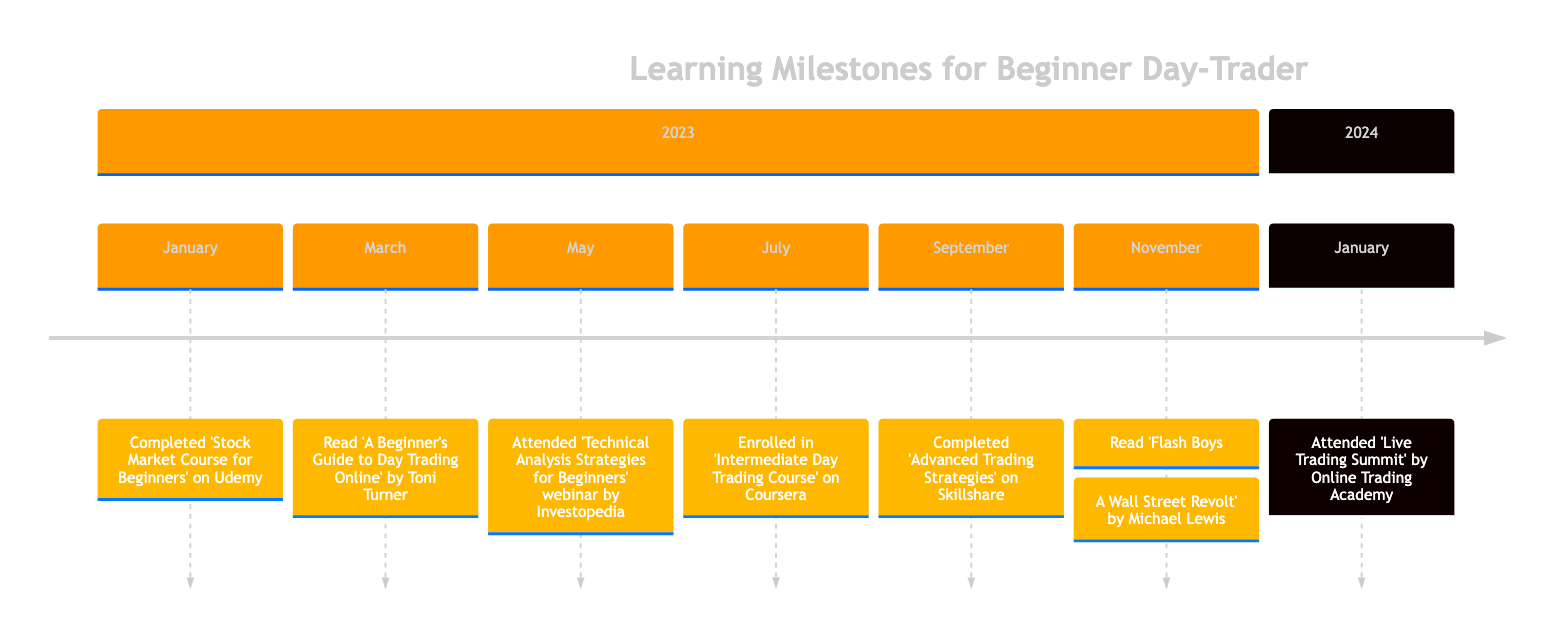What milestone was completed in January 2023? The diagram clearly states that in January 2023, the milestone "Completed 'Stock Market Course for Beginners' on Udemy" is depicted.
Answer: Completed 'Stock Market Course for Beginners' on Udemy How many books are listed in the timeline? By examining the timeline, there are two milestones that mention books, specifically the ones read in March and November.
Answer: 2 What course was taken in July 2023? The milestone for July 2023 specifically mentions enrolling in "Intermediate Day Trading Course" on Coursera.
Answer: Enrolled in 'Intermediate Day Trading Course' on Coursera Which webinar was attended before the advanced trading strategies course? The timeline reveals that the "Technical Analysis Strategies for Beginners" webinar was attended in May 2023, and the "Advanced Trading Strategies" course was completed in September 2023.
Answer: Attended 'Technical Analysis Strategies for Beginners' webinar by Investopedia In which month did the reader complete the advanced trading strategies course? The timeline shows that the "Advanced Trading Strategies" course was completed in September 2023.
Answer: September What was the last milestone recorded in the timeline? Looking at the timeline, the last entry is "Attended 'Live Trading Summit' by Online Trading Academy" in January 2024.
Answer: Attended 'Live Trading Summit' by Online Trading Academy Which book is focused on high-frequency trading? The diagram highlights "Flash Boys: A Wall Street Revolt" by Michael Lewis as the book that deals with high-frequency trading.
Answer: Flash Boys: A Wall Street Revolt What type of event was the "Live Trading Summit"? The timeline presents the "Live Trading Summit" as a conference featuring live trading sessions and expert panels.
Answer: Conference Which milestone occurred in March 2023? The entry for March 2023 states "Read 'A Beginner's Guide to Day Trading Online' by Toni Turner."
Answer: Read 'A Beginner's Guide to Day Trading Online' by Toni Turner 